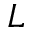<formula> <loc_0><loc_0><loc_500><loc_500>L</formula> 